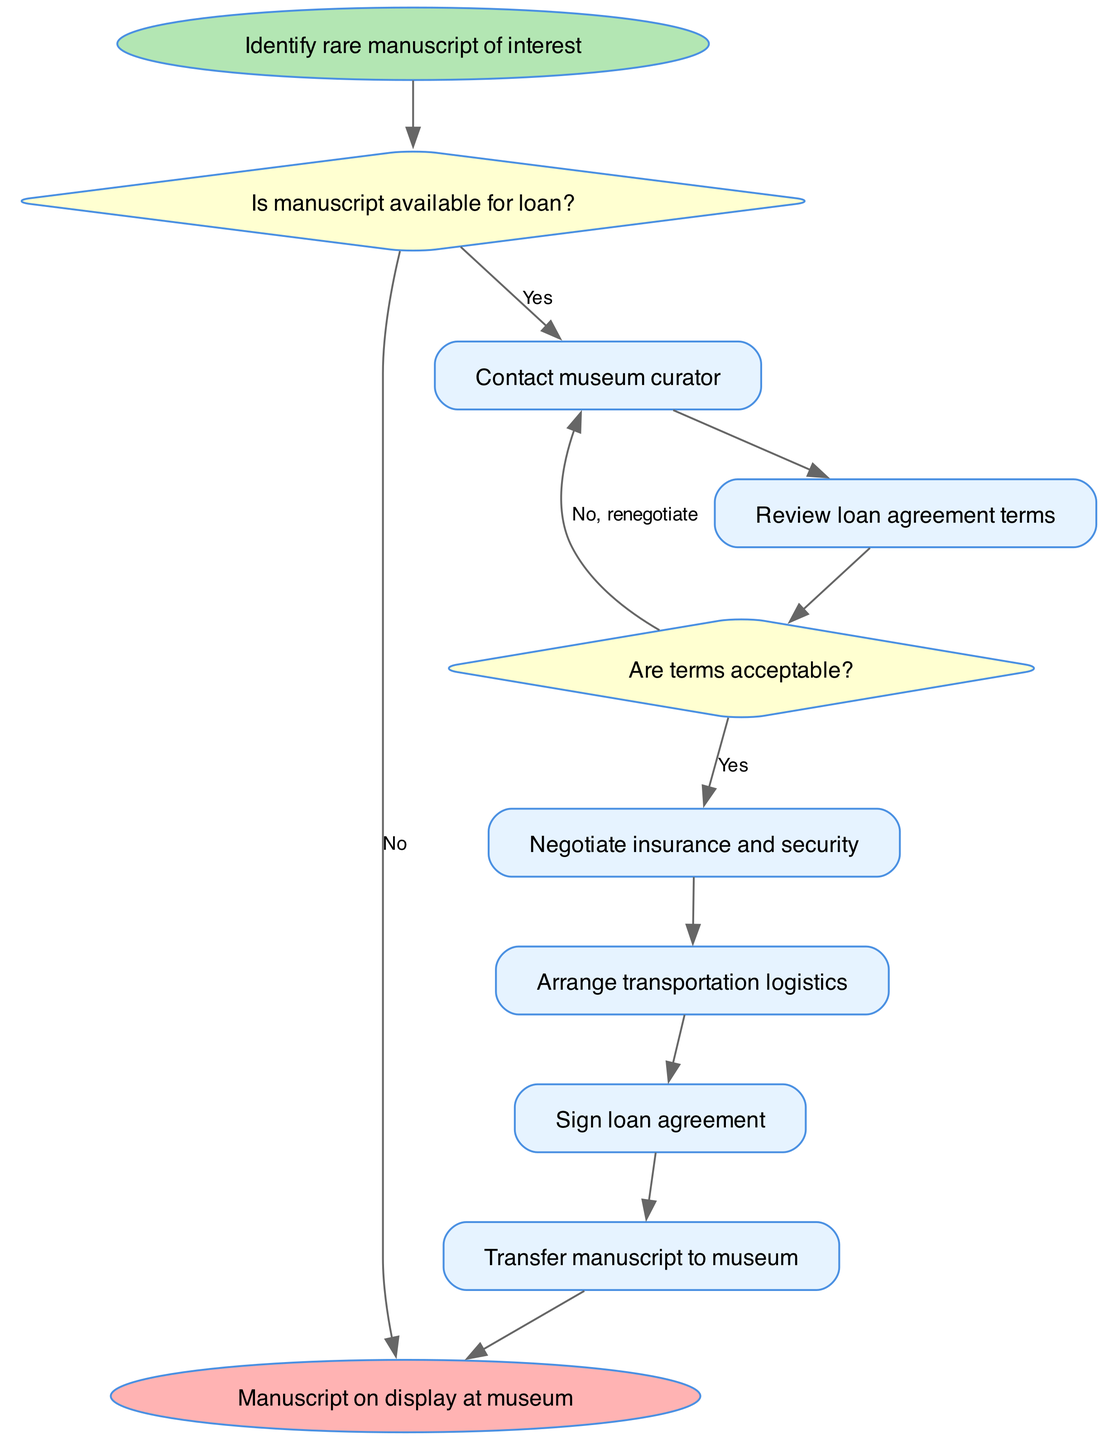What is the first step in the process? The first step listed in the diagram is labeled as "Identify rare manuscript of interest". This indicates that before any actions can be taken, the collector must establish what manuscript they are interested in.
Answer: Identify rare manuscript of interest What happens if the manuscript is not available for loan? According to the diagram, if the manuscript is not available for loan, the process ends immediately. There are no further steps involved when the manuscript is unavailable.
Answer: Manuscript on display at museum How many decision nodes are present in the diagram? By counting the nodes labeled as "decision" in the diagram, there are two decision nodes ("Is manuscript available for loan?" and "Are terms acceptable?"). This allows for branching of the process depending on the outcomes of these decisions.
Answer: 2 What is the next step after reviewing loan agreement terms? After reviewing the loan agreement terms, the diagram shows that the next step is to check if the terms are acceptable. This is a decision point that influences the subsequent actions.
Answer: Are terms acceptable? If the terms are not acceptable, what action follows? If the terms are not acceptable, the diagram indicates that the action that follows is to "Contact museum curator" again for renegotiation. This allows for adjustments to the terms before moving forward.
Answer: Contact museum curator What is one of the final steps before the manuscript is displayed? One of the final steps before the manuscript can be displayed at the museum is to "Sign loan agreement". This step is crucial as it formalizes the agreement allowing the manuscript to be loaned.
Answer: Sign loan agreement How many total steps are involved in the process? By counting all the distinct process nodes from the start to the end of the diagram, there are six total steps outlined in the flow of the manuscript negotiation process.
Answer: 6 What is the end result of successfully completing the process? The successful completion of the entire process culminates with the manuscript being on display at the museum. This is the final outcome intended from the negotiation and agreement steps.
Answer: Manuscript on display at museum 